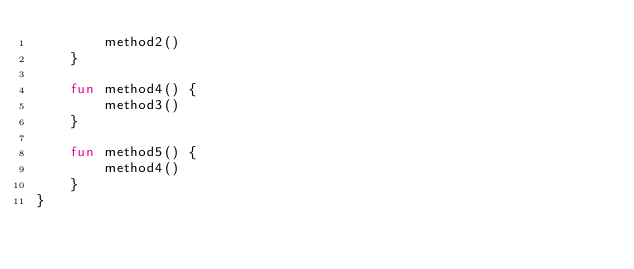<code> <loc_0><loc_0><loc_500><loc_500><_Kotlin_>        method2()
    }

    fun method4() {
        method3()
    }

    fun method5() {
        method4()
    }
}
</code> 